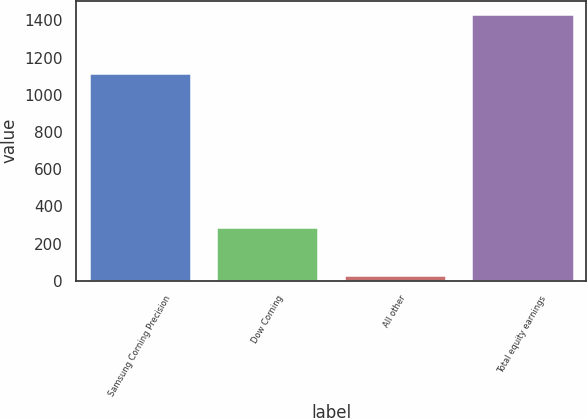Convert chart to OTSL. <chart><loc_0><loc_0><loc_500><loc_500><bar_chart><fcel>Samsung Corning Precision<fcel>Dow Corning<fcel>All other<fcel>Total equity earnings<nl><fcel>1115<fcel>287<fcel>33<fcel>1435<nl></chart> 